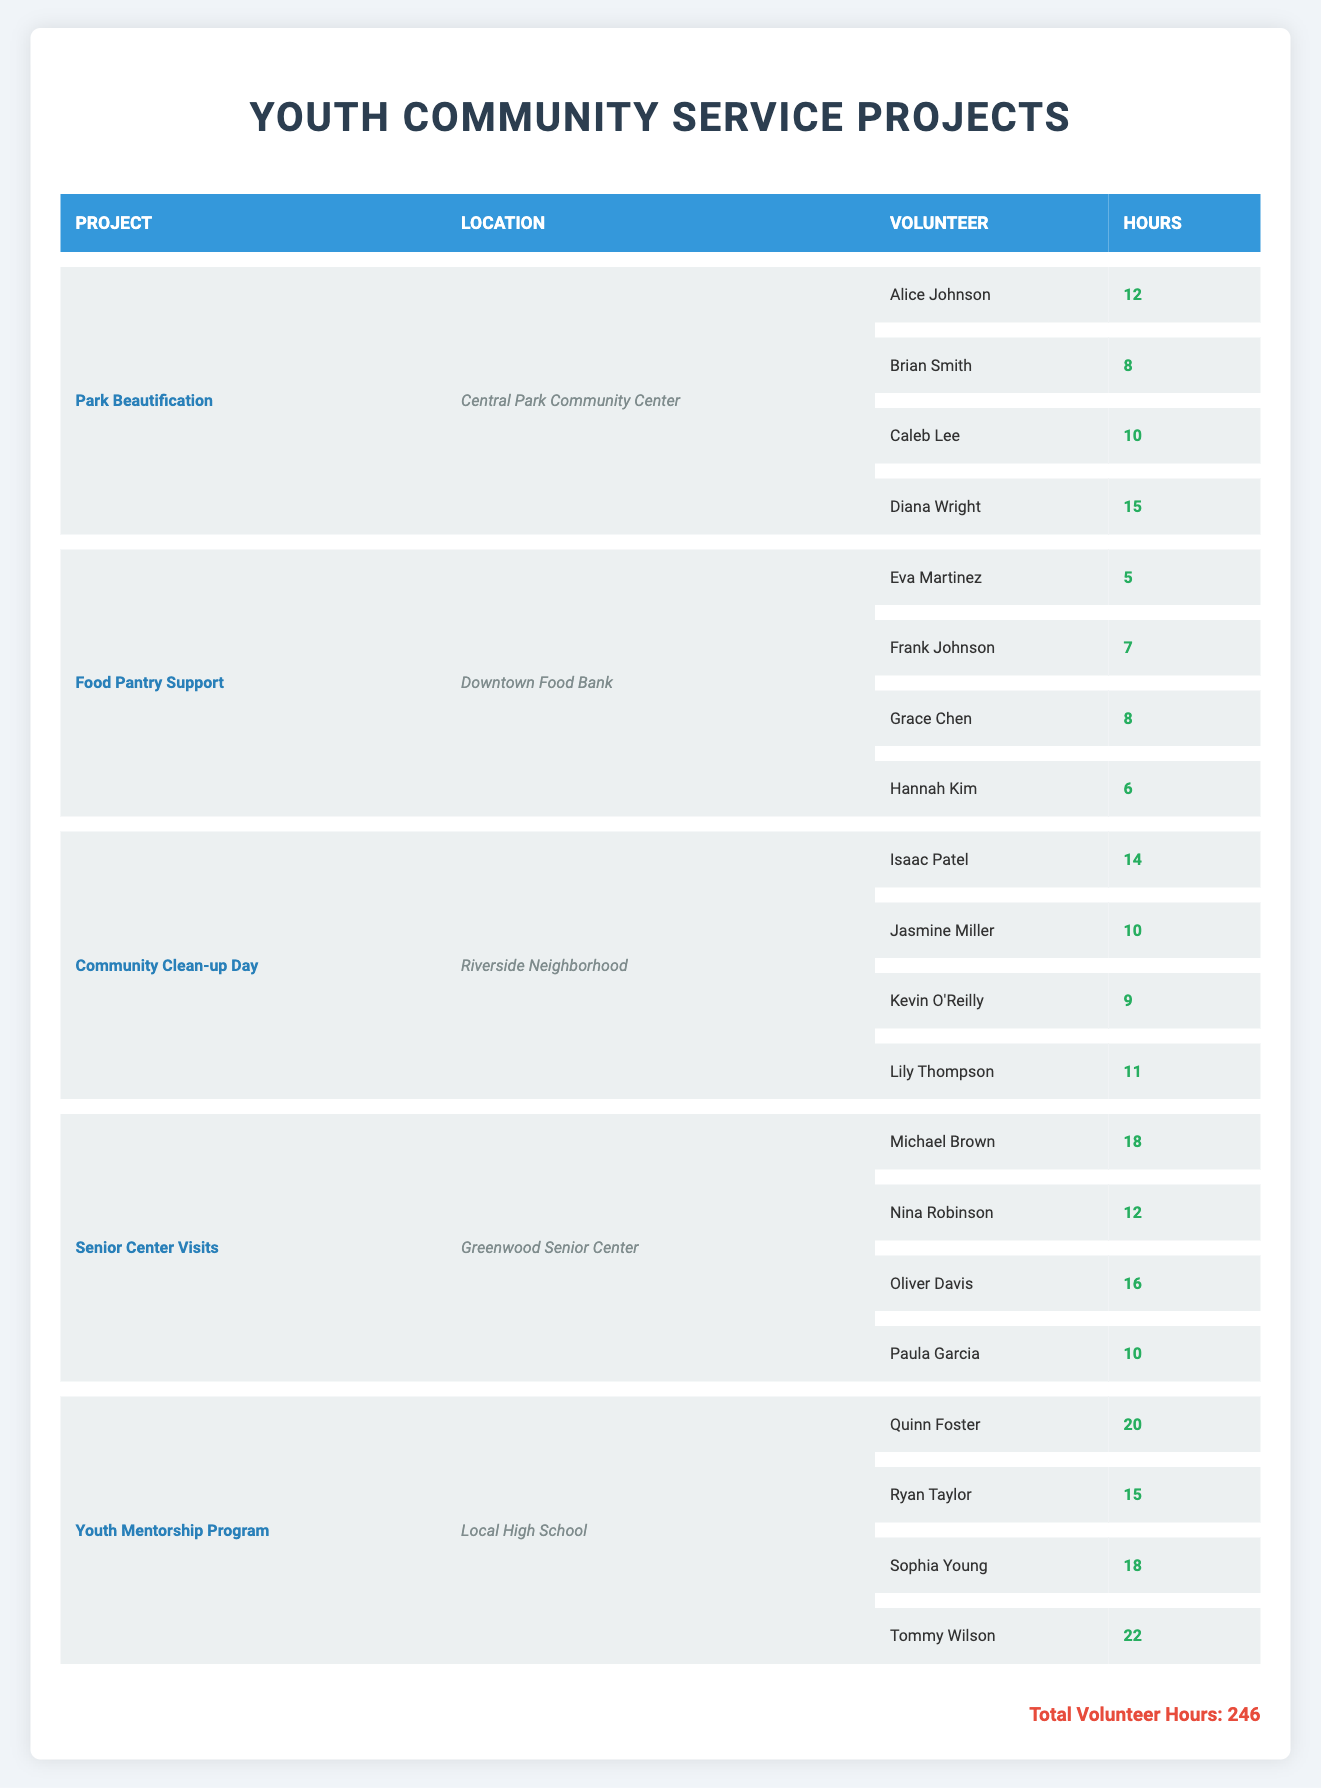What is the total number of hours contributed by the youth for the "Park Beautification" project? The "Park Beautification" project lists four youth volunteers: Alice Johnson (12 hours), Brian Smith (8 hours), Caleb Lee (10 hours), and Diana Wright (15 hours). We sum these hours: 12 + 8 + 10 + 15 = 45 hours.
Answer: 45 hours Who contributed the highest number of hours to the "Youth Mentorship Program"? Looking at the "Youth Mentorship Program," we see the following contributions: Quinn Foster (20 hours), Ryan Taylor (15 hours), Sophia Young (18 hours), and Tommy Wilson (22 hours). The highest contribution is from Tommy Wilson with 22 hours.
Answer: Tommy Wilson How many youth volunteers contributed to the "Food Pantry Support" project? The "Food Pantry Support" project has four volunteers: Eva Martinez, Frank Johnson, Grace Chen, and Hannah Kim. The total number of youth volunteers is 4.
Answer: 4 volunteers What is the average number of hours contributed by youth volunteers across all projects? To find the average, we first need the total hours contributed across all projects. The total hours from the data add up to 246. There are 20 individual contributions from all projects (4 for each of the 5 projects). The average is calculated as 246/20 = 12.3 hours.
Answer: 12.3 hours Which project had the highest total volunteer hours? The total hours for each project are as follows: Park Beautification (45), Food Pantry Support (26), Community Clean-up Day (44), Senior Center Visits (56), and Youth Mentorship Program (75). The Youth Mentorship Program has the highest total at 75 hours.
Answer: Youth Mentorship Program Did any youth volunteer for both the "Community Clean-up Day" and "Senior Center Visits"? Comparing the volunteers for both projects, the "Community Clean-up Day" had Isaac Patel, Jasmine Miller, Kevin O'Reilly, and Lily Thompson, while the "Senior Center Visits" had Michael Brown, Nina Robinson, Oliver Davis, and Paula Garcia. There are no overlapping names, so the answer is no.
Answer: No What is the total number of hours contributed by the youth in the "Senior Center Visits" project? For the "Senior Center Visits" project, the youth contributions are: Michael Brown (18 hours), Nina Robinson (12 hours), Oliver Davis (16 hours), and Paula Garcia (10 hours). Adding those together gives us 18 + 12 + 16 + 10 = 56 hours.
Answer: 56 hours How many more hours did Tommy Wilson contribute compared to Hannah Kim? Tommy Wilson contributed 22 hours in the "Youth Mentorship Program," while Hannah Kim contributed 6 hours in the "Food Pantry Support." The difference is 22 - 6 = 16 hours more contributed by Tommy.
Answer: 16 hours What percentage of the total volunteer hours does the "Community Clean-up Day" represent? The total hours for "Community Clean-up Day" is 44. To find the percentage, we use the formula: (44/246) * 100. This equals approximately 17.9%.
Answer: 17.9% Which youth contributed exactly 10 hours, and in which projects did they participate? The individuals contributing exactly 10 hours are Caleb Lee (Park Beautification) and Lily Thompson (Community Clean-up Day) and Paula Garcia (Senior Center Visits). Each contributed 10 hours in their respective projects.
Answer: Caleb Lee, Lily Thompson, Paula Garcia 